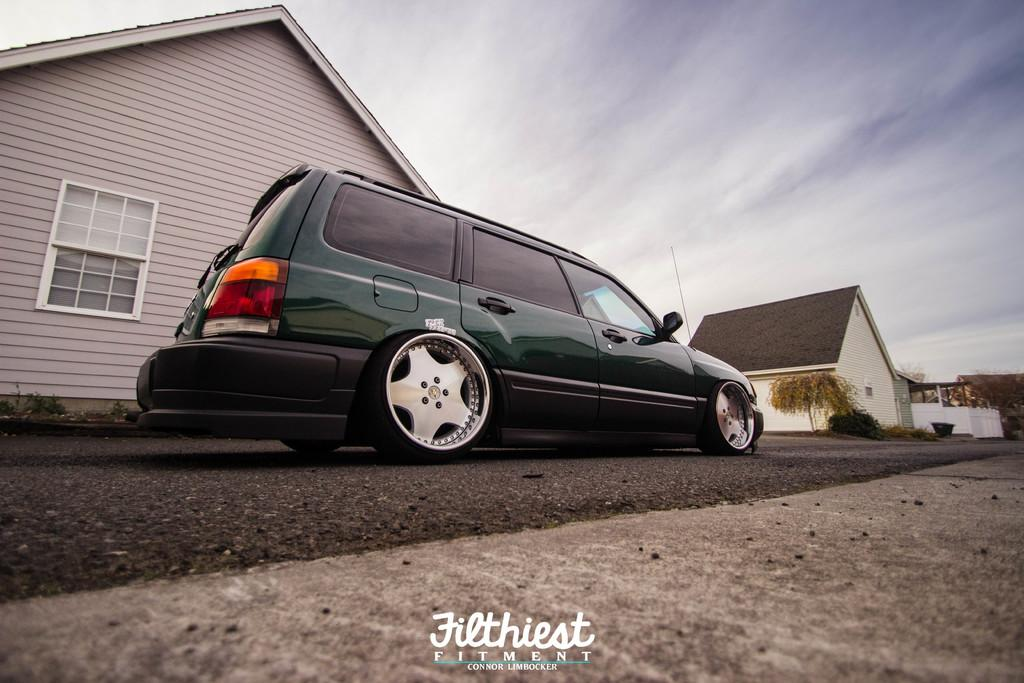What is the main subject of the image? There is a vehicle on the road in the image. What else can be seen in the image besides the vehicle? There are houses, trees, and the sky visible in the image. Can you describe the background of the image? The sky is visible in the background of the image. Is there any additional information about the image? Yes, there is a watermark on the image. How many stars are visible in the image? There are no stars visible in the image. 